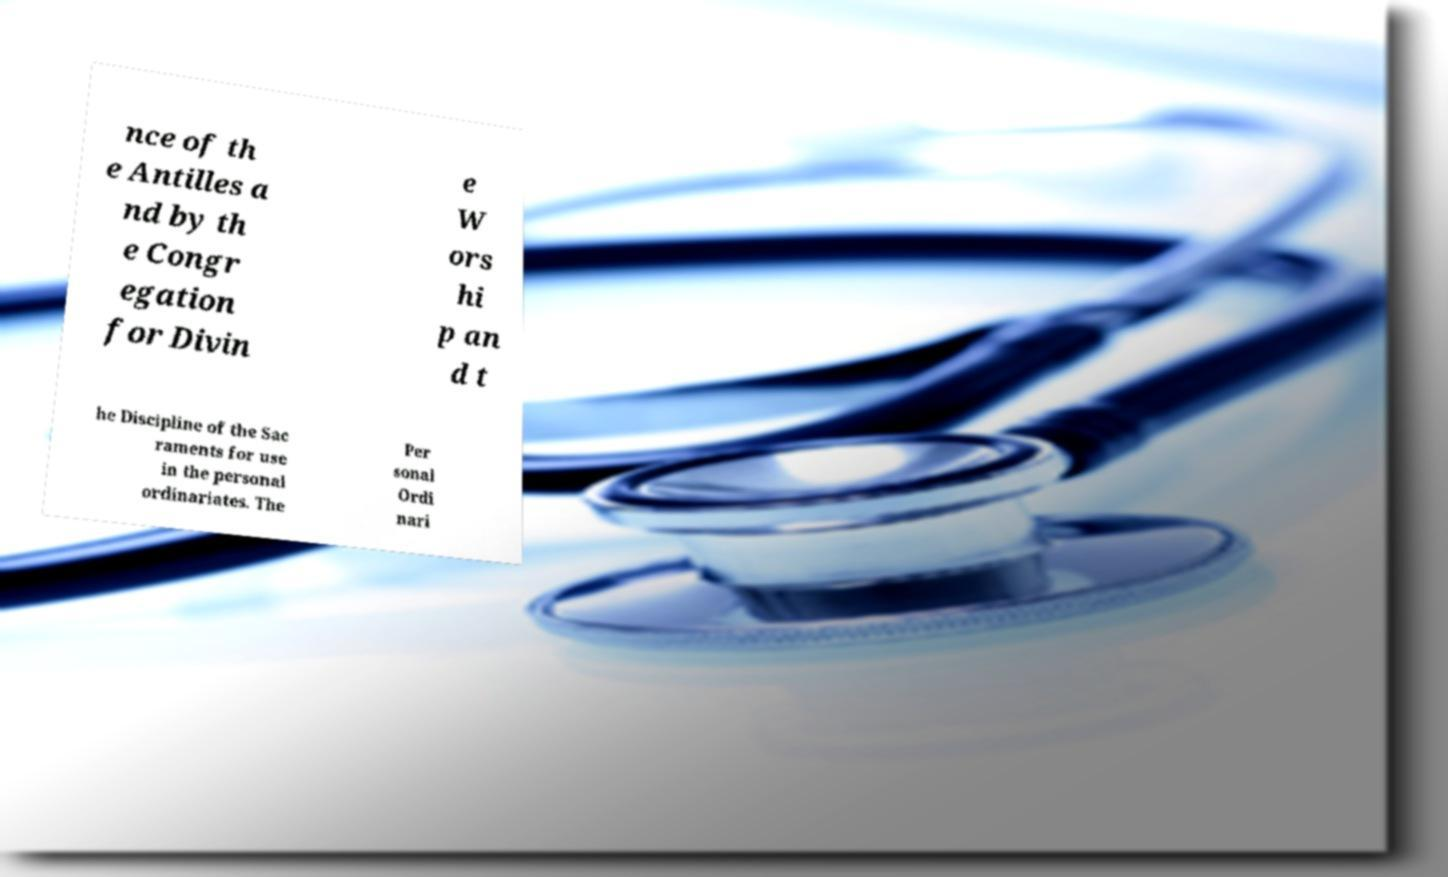Please read and relay the text visible in this image. What does it say? nce of th e Antilles a nd by th e Congr egation for Divin e W ors hi p an d t he Discipline of the Sac raments for use in the personal ordinariates. The Per sonal Ordi nari 